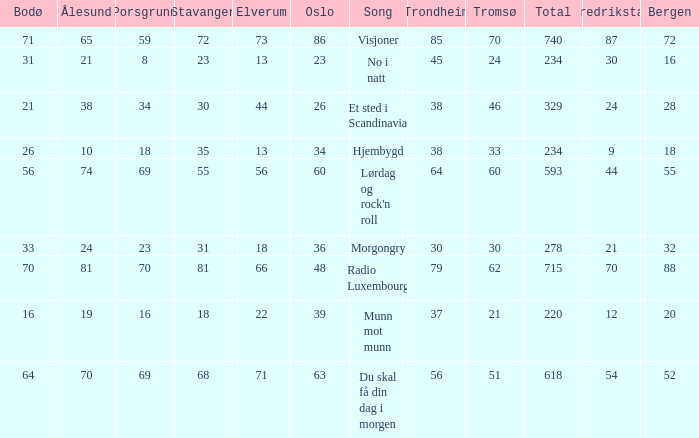What is the lowest total? 220.0. 